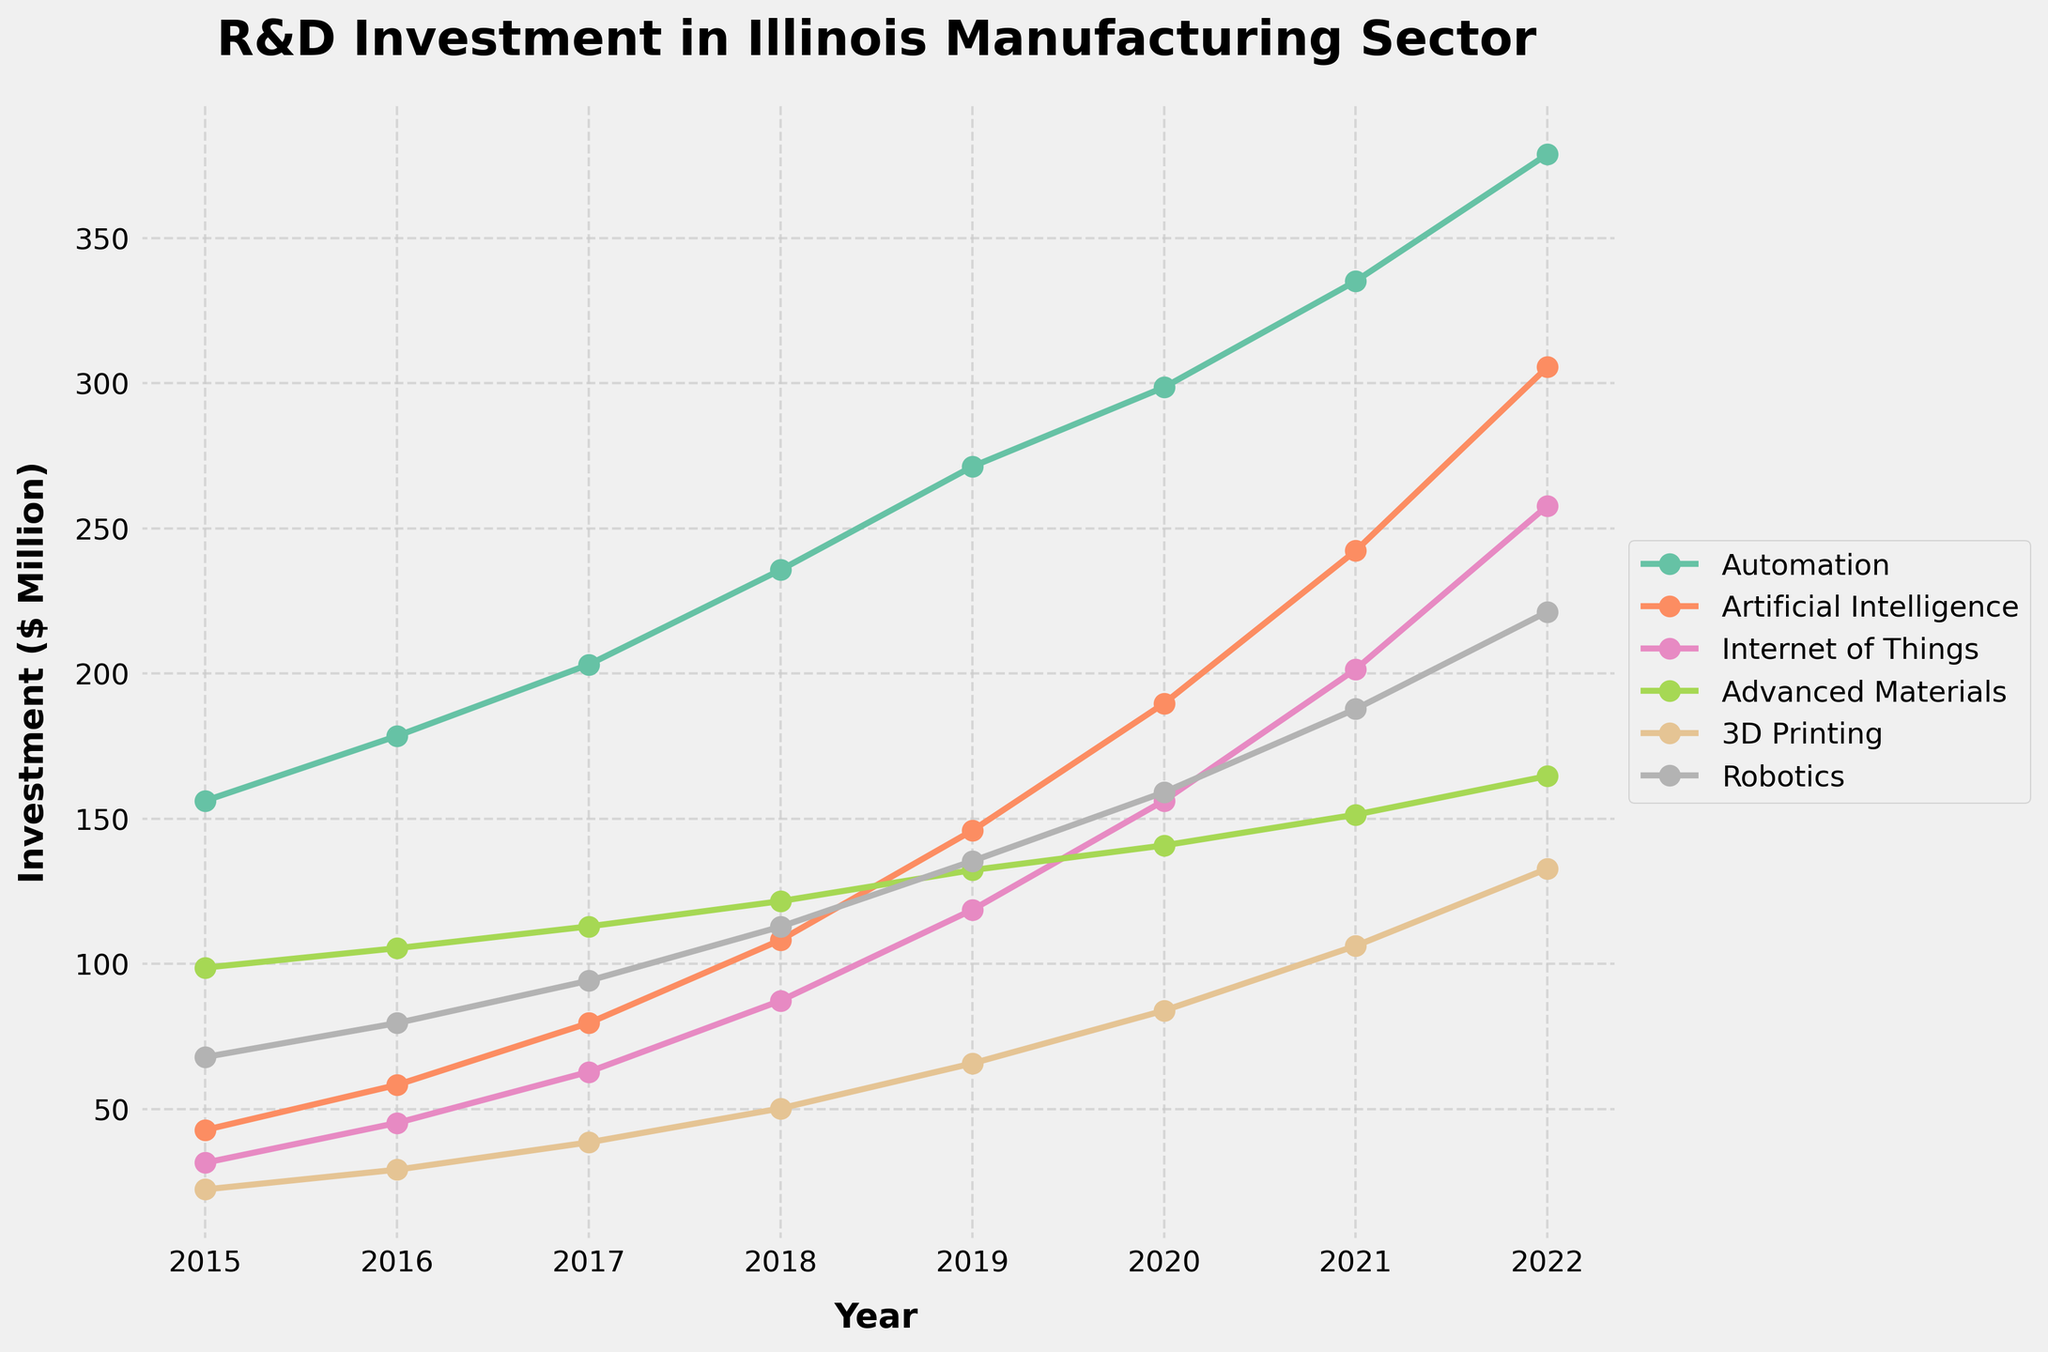What was the total R&D investment for Automation between 2015 and 2022? To get the total investment for Automation, add the values for each year: 156.2 + 178.5 + 203.1 + 235.7 + 271.3 + 298.6 + 335.2 + 378.9 = 2057.5 million dollars.
Answer: 2057.5 million dollars In which year did Advanced Materials see the highest R&D investment? From the data, Advanced Materials saw the highest investment in 2022 with 164.7 million dollars.
Answer: 2022 How much did the R&D investment in AI increase from 2016 to 2019? To find the increase, subtract the 2016 value from the 2019 value: 145.9 - 58.3 = 87.6 million dollars increase.
Answer: 87.6 million dollars Which technology area had the smallest investment in 2015 and how much was it? In 2015, Internet of Things had the smallest investment with 31.5 million dollars.
Answer: Internet of Things, 31.5 million dollars Compare the R&D investment in 3D Printing to that in Robotics in 2018. Which one received more funding and by how much? In 2018, 3D Printing received 50.2 million dollars, and Robotics received 112.8 million dollars. The difference is 112.8 - 50.2 = 62.6 million dollars, so Robotics received more funding by 62.6 million dollars.
Answer: Robotics, 62.6 million dollars What is the average yearly R&D investment in Robotics from 2015 to 2022? The average yearly investment is calculated by summing the yearly investments and dividing by the number of years. The total investment is 67.9 + 79.6 + 94.2 + 112.8 + 135.4 + 159.1 + 187.8 + 221.3 = 1058.1 million dollars. Dividing by 8 years gives an average of 1058.1 / 8 = 132.26 million dollars per year.
Answer: 132.26 million dollars Which R&D area had the most significant increase in investment from 2015 to 2022? To identify the area with the most significant increase, calculate the difference between the 2022 and 2015 values for each category: Automation: 378.9 - 156.2 = 222.7 AI: 305.6 - 42.8 = 262.8 IoT: 257.8 - 31.5 = 226.3 Advanced Materials: 164.7 - 98.7 = 66.0 3D Printing: 132.8 - 22.3 = 110.5 Robotics: 221.3 - 67.9 = 153.4 The most significant increase is in AI with 262.8 million dollars.
Answer: Artificial Intelligence, 262.8 million dollars What was the combined R&D investment in IoT and Robotics in 2021? Add the 2021 values for IoT and Robotics: 201.5 + 187.8 = 389.3 million dollars.
Answer: 389.3 million dollars Has there been a consistent increase in R&D investment in Advanced Materials every year from 2015 to 2022? Examine the yearly investments for Advanced Materials: 98.7, 105.4, 112.9, 121.6, 132.3, 140.8, 151.4, 164.7. Each year, the investment has indeed increased consistently.
Answer: Yes 